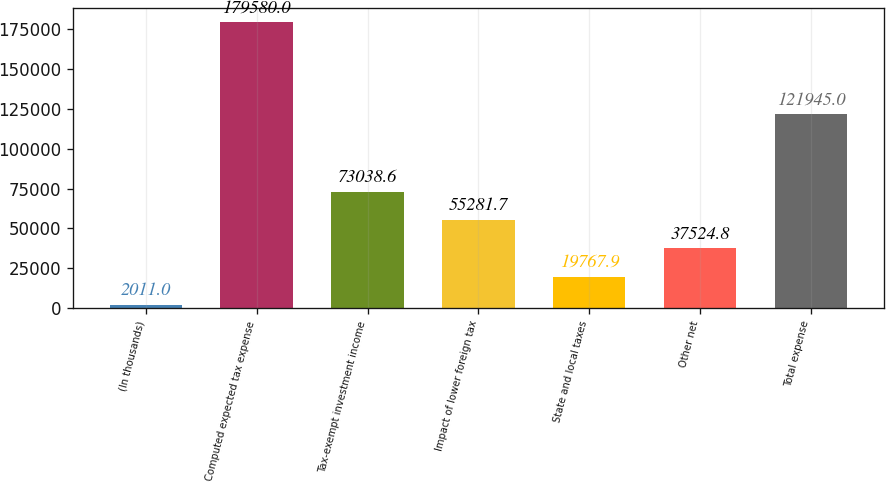Convert chart. <chart><loc_0><loc_0><loc_500><loc_500><bar_chart><fcel>(In thousands)<fcel>Computed expected tax expense<fcel>Tax-exempt investment income<fcel>Impact of lower foreign tax<fcel>State and local taxes<fcel>Other net<fcel>Total expense<nl><fcel>2011<fcel>179580<fcel>73038.6<fcel>55281.7<fcel>19767.9<fcel>37524.8<fcel>121945<nl></chart> 